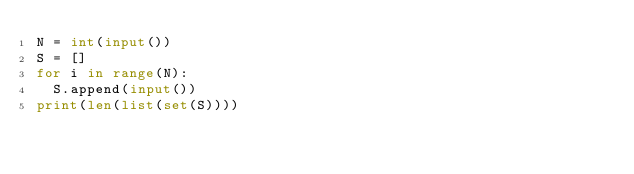Convert code to text. <code><loc_0><loc_0><loc_500><loc_500><_Python_>N = int(input())
S = []
for i in range(N):
  S.append(input())
print(len(list(set(S))))</code> 